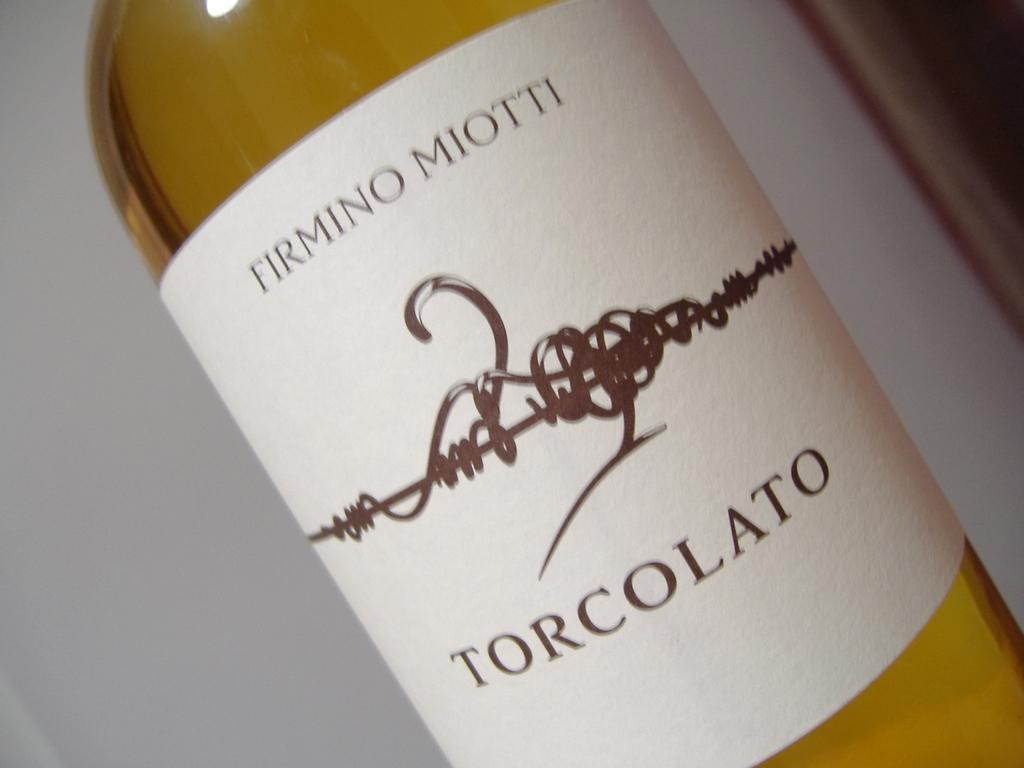Provide a one-sentence caption for the provided image. "FIRMINO MIOTTI TORCOLATO" is on a wine label. 